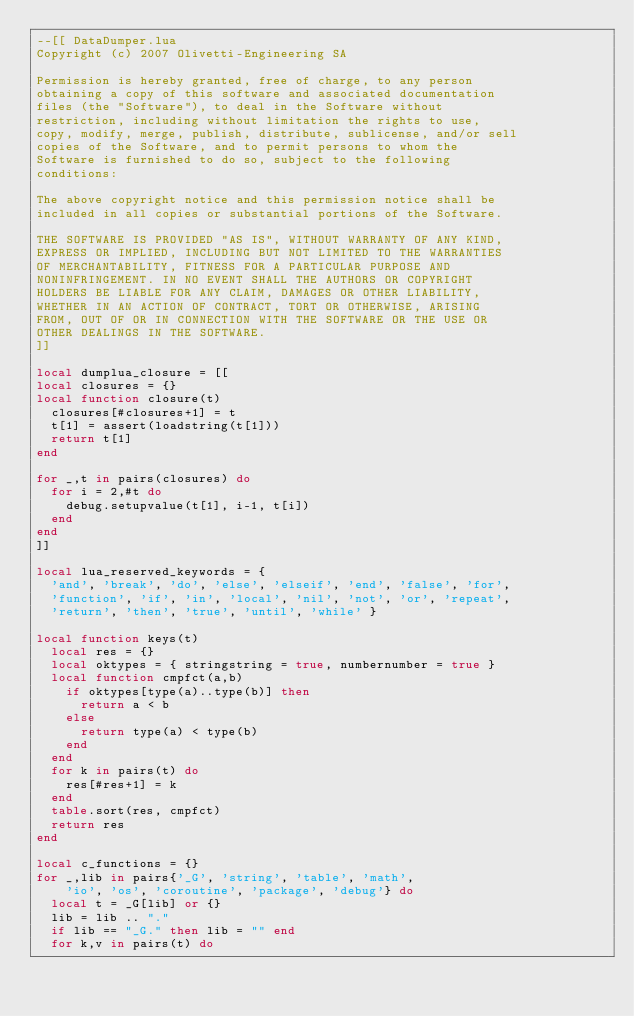<code> <loc_0><loc_0><loc_500><loc_500><_Lua_>--[[ DataDumper.lua
Copyright (c) 2007 Olivetti-Engineering SA

Permission is hereby granted, free of charge, to any person
obtaining a copy of this software and associated documentation
files (the "Software"), to deal in the Software without
restriction, including without limitation the rights to use,
copy, modify, merge, publish, distribute, sublicense, and/or sell
copies of the Software, and to permit persons to whom the
Software is furnished to do so, subject to the following
conditions:

The above copyright notice and this permission notice shall be
included in all copies or substantial portions of the Software.

THE SOFTWARE IS PROVIDED "AS IS", WITHOUT WARRANTY OF ANY KIND,
EXPRESS OR IMPLIED, INCLUDING BUT NOT LIMITED TO THE WARRANTIES
OF MERCHANTABILITY, FITNESS FOR A PARTICULAR PURPOSE AND
NONINFRINGEMENT. IN NO EVENT SHALL THE AUTHORS OR COPYRIGHT
HOLDERS BE LIABLE FOR ANY CLAIM, DAMAGES OR OTHER LIABILITY,
WHETHER IN AN ACTION OF CONTRACT, TORT OR OTHERWISE, ARISING
FROM, OUT OF OR IN CONNECTION WITH THE SOFTWARE OR THE USE OR
OTHER DEALINGS IN THE SOFTWARE.
]]

local dumplua_closure = [[
local closures = {}
local function closure(t) 
  closures[#closures+1] = t
  t[1] = assert(loadstring(t[1]))
  return t[1]
end

for _,t in pairs(closures) do
  for i = 2,#t do 
    debug.setupvalue(t[1], i-1, t[i]) 
  end 
end
]]

local lua_reserved_keywords = {
  'and', 'break', 'do', 'else', 'elseif', 'end', 'false', 'for', 
  'function', 'if', 'in', 'local', 'nil', 'not', 'or', 'repeat', 
  'return', 'then', 'true', 'until', 'while' }

local function keys(t)
  local res = {}
  local oktypes = { stringstring = true, numbernumber = true }
  local function cmpfct(a,b)
    if oktypes[type(a)..type(b)] then
      return a < b
    else
      return type(a) < type(b)
    end
  end
  for k in pairs(t) do
    res[#res+1] = k
  end
  table.sort(res, cmpfct)
  return res
end

local c_functions = {}
for _,lib in pairs{'_G', 'string', 'table', 'math', 
    'io', 'os', 'coroutine', 'package', 'debug'} do
  local t = _G[lib] or {}
  lib = lib .. "."
  if lib == "_G." then lib = "" end
  for k,v in pairs(t) do</code> 